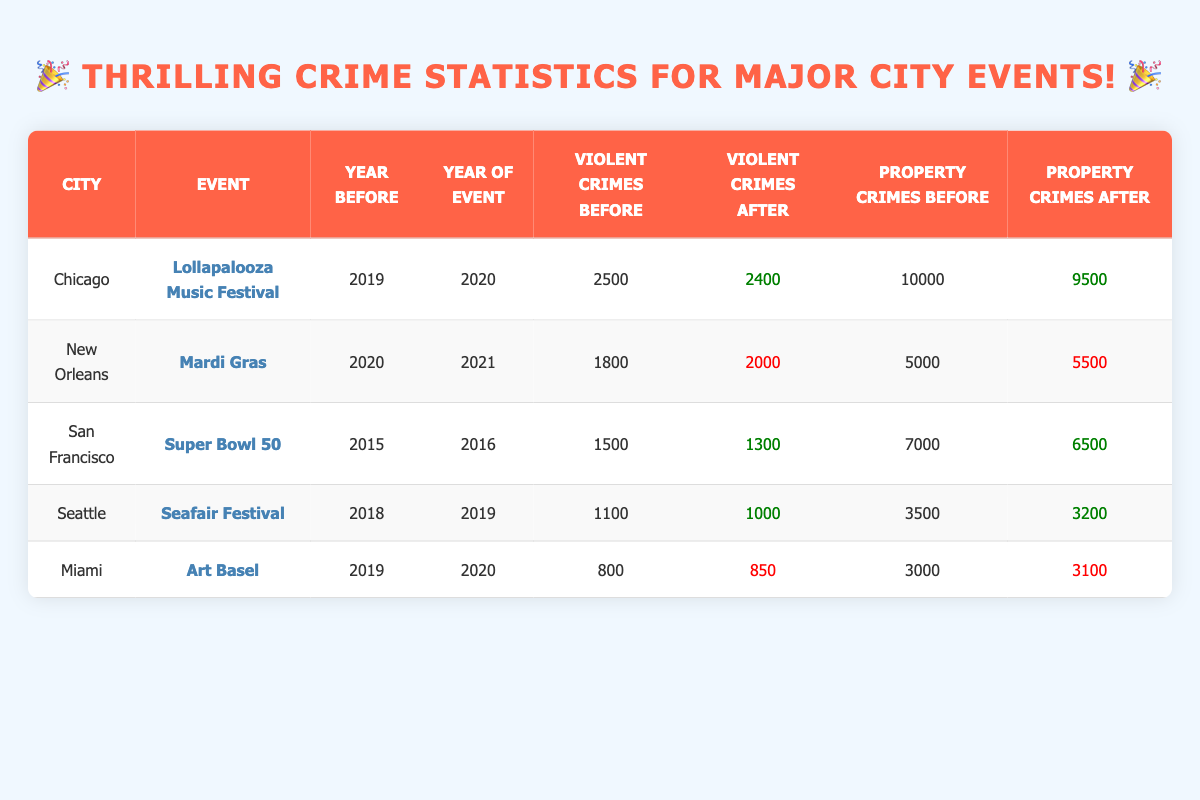What was the total number of violent crimes in Chicago before the Lollapalooza Music Festival? According to the table, the number of violent crimes in Chicago before the event was recorded as 2500.
Answer: 2500 Did violent crimes increase or decrease in San Francisco after the Super Bowl 50? The data shows that violent crimes decreased from 1500 before the event to 1300 after, indicating a reduction.
Answer: Decrease What is the difference in property crimes in New Orleans before and after Mardi Gras? Before Mardi Gras, property crimes were 5000, and after they increased to 5500. The difference is calculated as 5500 - 5000 = 500.
Answer: 500 In which city did property crimes decrease after the event? A review of the table reveals that both Chicago and San Francisco saw decreases in property crimes after their respective events, with numbers dropping from 10000 to 9500 and from 7000 to 6500.
Answer: Chicago and San Francisco What is the average number of violent crimes before the events across all cities represented? The total number of violent crimes before events is 2500 (Chicago) + 1800 (New Orleans) + 1500 (San Francisco) + 1100 (Seattle) + 800 (Miami) = 6900. There are 5 cities, so the average is 6900 / 5 = 1380.
Answer: 1380 Did Miami experience a decrease in violent crimes after Art Basel? The violent crimes in Miami increased from 800 before the event to 850 afterwards, signifying an increase rather than a decrease.
Answer: No Which event resulted in the highest increase in property crimes? Analyzing the data, Mardi Gras in New Orleans had the highest increase in property crimes from 5000 to 5500, an increase of 500.
Answer: Mardi Gras What was the total number of violent crimes after the Lollapalooza Music Festival? After the event, Chicago reported 2400 violent crimes, and none of the other cities experienced more cases than this, confirming it as the total after this specific event.
Answer: 2400 